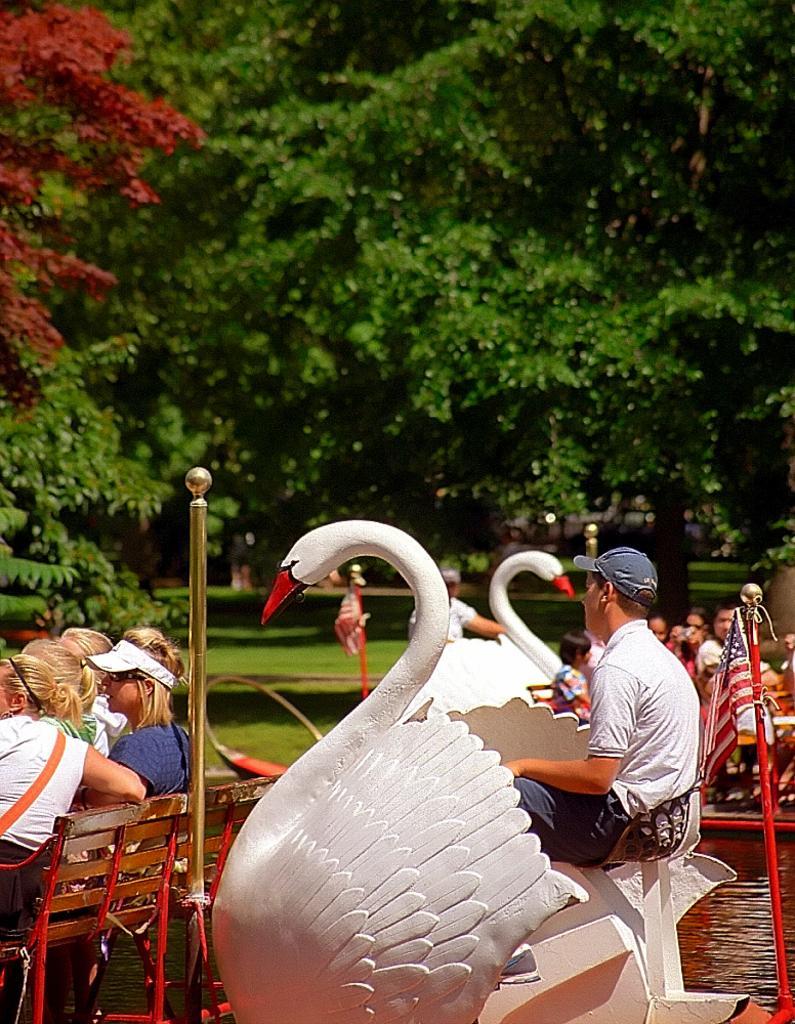How would you summarize this image in a sentence or two? in this image, in the middle, we can see a man sitting on the bench. On the left side, we can see a group of people sitting on the bench. On the right side, we can see a flag and group of people, we can also see a water. In the background, we can see some trees, metal rod, at the bottom there is a grass. 